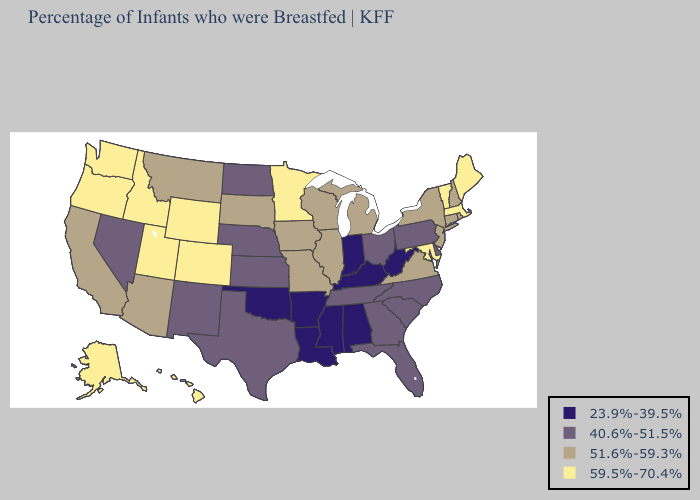What is the value of Mississippi?
Concise answer only. 23.9%-39.5%. What is the highest value in states that border Tennessee?
Keep it brief. 51.6%-59.3%. What is the value of Alabama?
Write a very short answer. 23.9%-39.5%. What is the highest value in the Northeast ?
Concise answer only. 59.5%-70.4%. Is the legend a continuous bar?
Concise answer only. No. Does Wisconsin have the highest value in the USA?
Concise answer only. No. What is the highest value in states that border Wyoming?
Quick response, please. 59.5%-70.4%. What is the value of Delaware?
Concise answer only. 40.6%-51.5%. Which states have the lowest value in the USA?
Answer briefly. Alabama, Arkansas, Indiana, Kentucky, Louisiana, Mississippi, Oklahoma, West Virginia. Name the states that have a value in the range 51.6%-59.3%?
Answer briefly. Arizona, California, Connecticut, Illinois, Iowa, Michigan, Missouri, Montana, New Hampshire, New Jersey, New York, Rhode Island, South Dakota, Virginia, Wisconsin. What is the highest value in the MidWest ?
Short answer required. 59.5%-70.4%. Does Alabama have a lower value than Hawaii?
Keep it brief. Yes. What is the highest value in the USA?
Quick response, please. 59.5%-70.4%. Name the states that have a value in the range 40.6%-51.5%?
Write a very short answer. Delaware, Florida, Georgia, Kansas, Nebraska, Nevada, New Mexico, North Carolina, North Dakota, Ohio, Pennsylvania, South Carolina, Tennessee, Texas. What is the value of South Dakota?
Answer briefly. 51.6%-59.3%. 